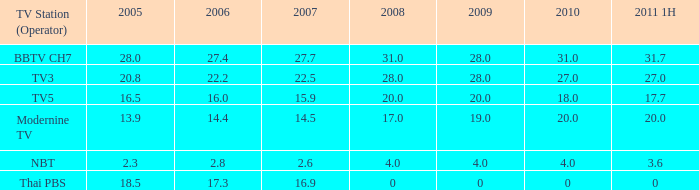4 and 2007 above 2 0.0. 